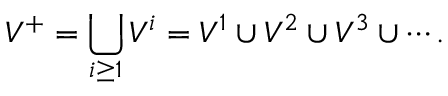Convert formula to latex. <formula><loc_0><loc_0><loc_500><loc_500>V ^ { + } = \bigcup _ { i \geq 1 } V ^ { i } = V ^ { 1 } \cup V ^ { 2 } \cup V ^ { 3 } \cup \cdots .</formula> 